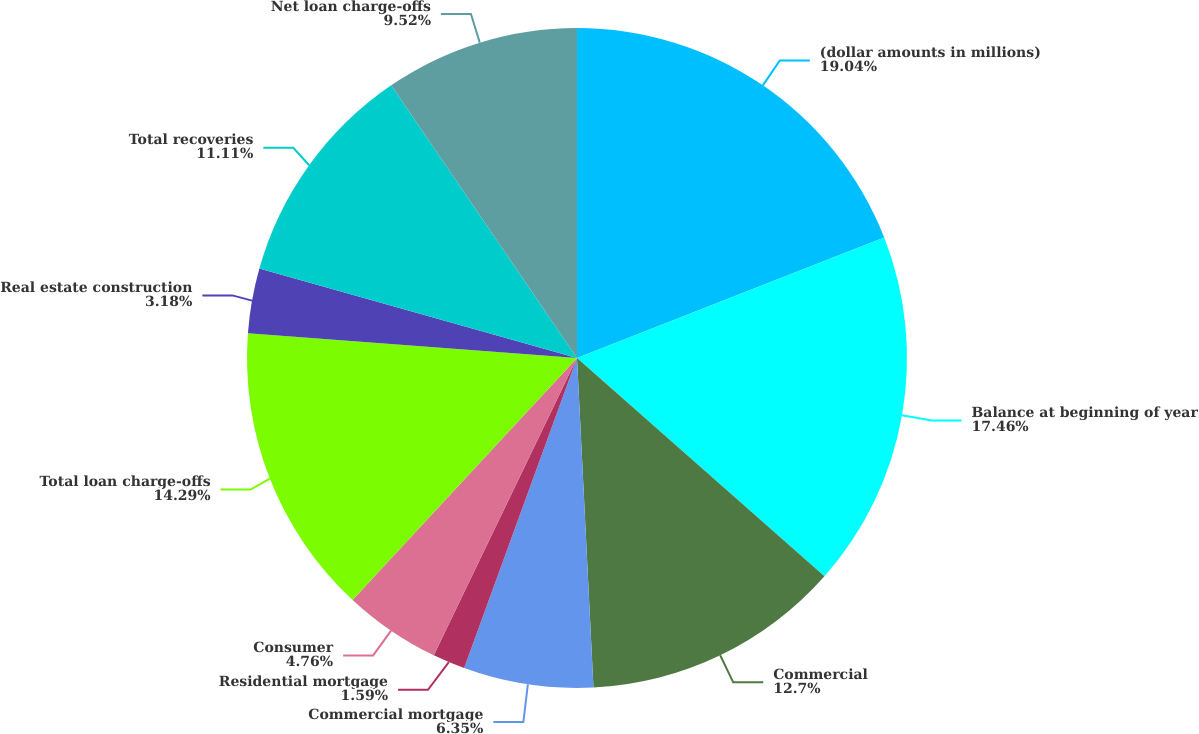<chart> <loc_0><loc_0><loc_500><loc_500><pie_chart><fcel>(dollar amounts in millions)<fcel>Balance at beginning of year<fcel>Commercial<fcel>Commercial mortgage<fcel>Residential mortgage<fcel>Consumer<fcel>Total loan charge-offs<fcel>Real estate construction<fcel>Total recoveries<fcel>Net loan charge-offs<nl><fcel>19.05%<fcel>17.46%<fcel>12.7%<fcel>6.35%<fcel>1.59%<fcel>4.76%<fcel>14.29%<fcel>3.18%<fcel>11.11%<fcel>9.52%<nl></chart> 